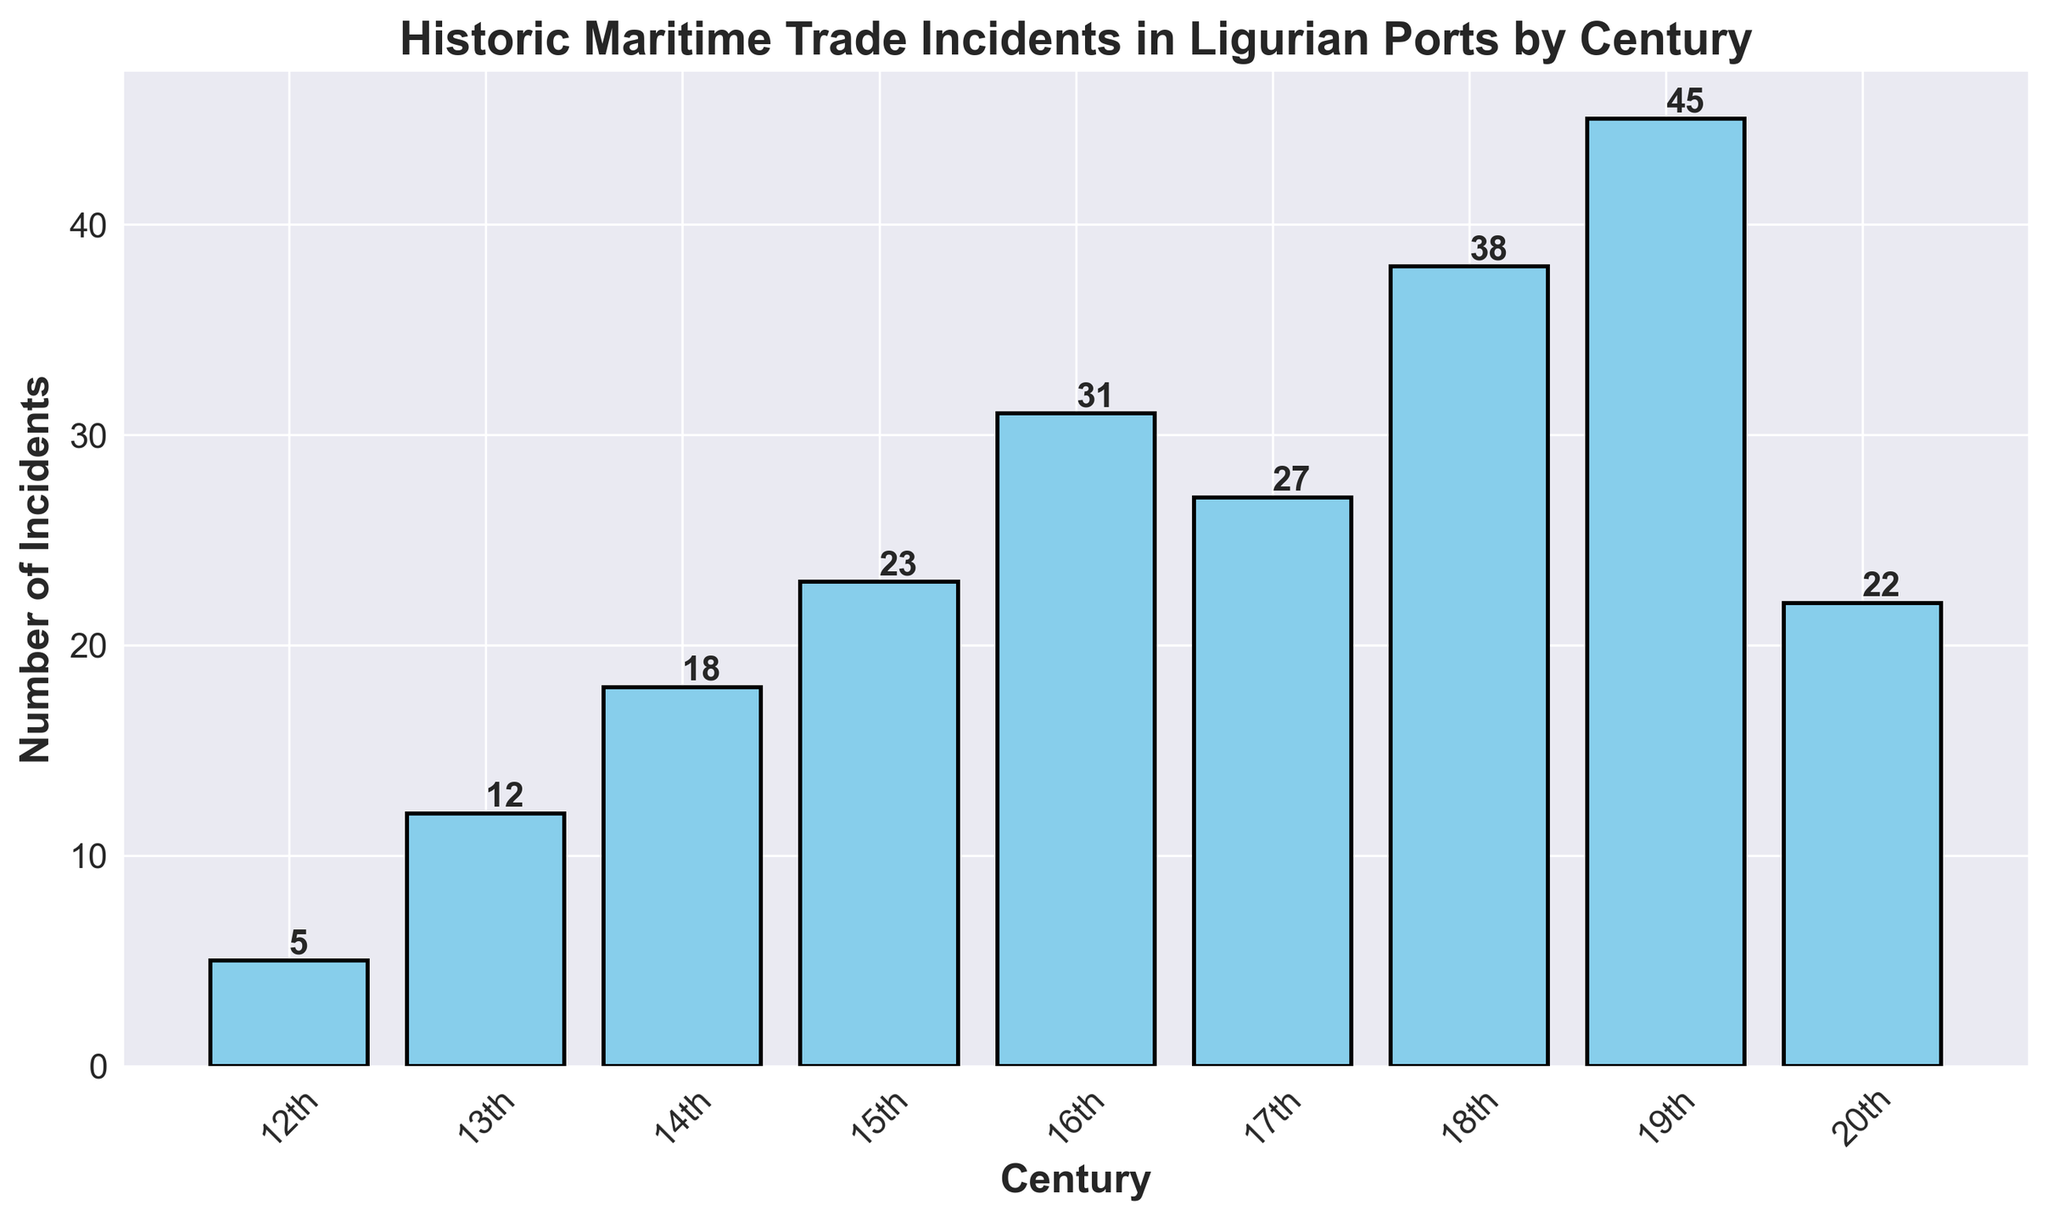What's the century with the highest number of incidents? To find the century with the highest number of incidents, we compare the heights of all bars in the histogram. The bar representing the 19th century is the tallest, indicating the highest number of incidents.
Answer: 19th century What is the total number of incidents from the 12th to the 15th centuries? Add the number of incidents from the 12th, 13th, 14th, and 15th centuries. These values are 5, 12, 18, and 23, respectively. Summing these, 5 + 12 + 18 + 23 = 58.
Answer: 58 Which two consecutive centuries have the largest increase in the number of incidents? Calculate the difference in the number of incidents between consecutive centuries. The differences are: 12th-13th (7), 13th-14th (6), 14th-15th (5), 15th-16th (8), 16th-17th (-4), 17th-18th (11), 18th-19th (7), 19th-20th (-23). The 17th to 18th centuries have the largest increase with a difference of 11.
Answer: 17th to 18th centuries How does the number of incidents in the 20th century compare to that in the 16th century? Compare the heights of the bars representing the 20th and 16th centuries. The 20th century has 22 incidents, and the 16th century has 31 incidents, so the 20th century has fewer incidents than the 16th.
Answer: Fewer What is the average number of incidents per century shown in the histogram? Sum all the incidents from each century and divide by the number of centuries. The total number of incidents is 5 + 12 + 18 + 23 + 31 + 27 + 38 + 45 + 22 = 221. There are 9 centuries, so the average is 221 / 9 ≈ 24.56.
Answer: ≈ 24.56 Identify the centuries where the number of incidents exceeds the average number of incidents calculated previously. The previously calculated average is approximately 24.56 incidents. Centuries with incidents exceeding this average are those with values: 31 (16th), 27 (17th), 38 (18th), and 45 (19th).
Answer: 16th, 17th, 18th, 19th centuries By how many incidents did the 19th century exceed the first three centuries combined? Sum the incidents of the 12th, 13th, and 14th centuries: 5 + 12 + 18 = 35. The 19th century had 45 incidents. The difference is 45 - 35 = 10.
Answer: 10 Which century has the second highest number of incidents? By examining the heights of the bars, the century with the second highest number of incidents is the 18th century with 38 incidents.
Answer: 18th century What is the total number of incidents reported in the 18th and 19th centuries together? Add the number of incidents in the 18th century (38) and the 19th century (45). The total is 38 + 45 = 83.
Answer: 83 